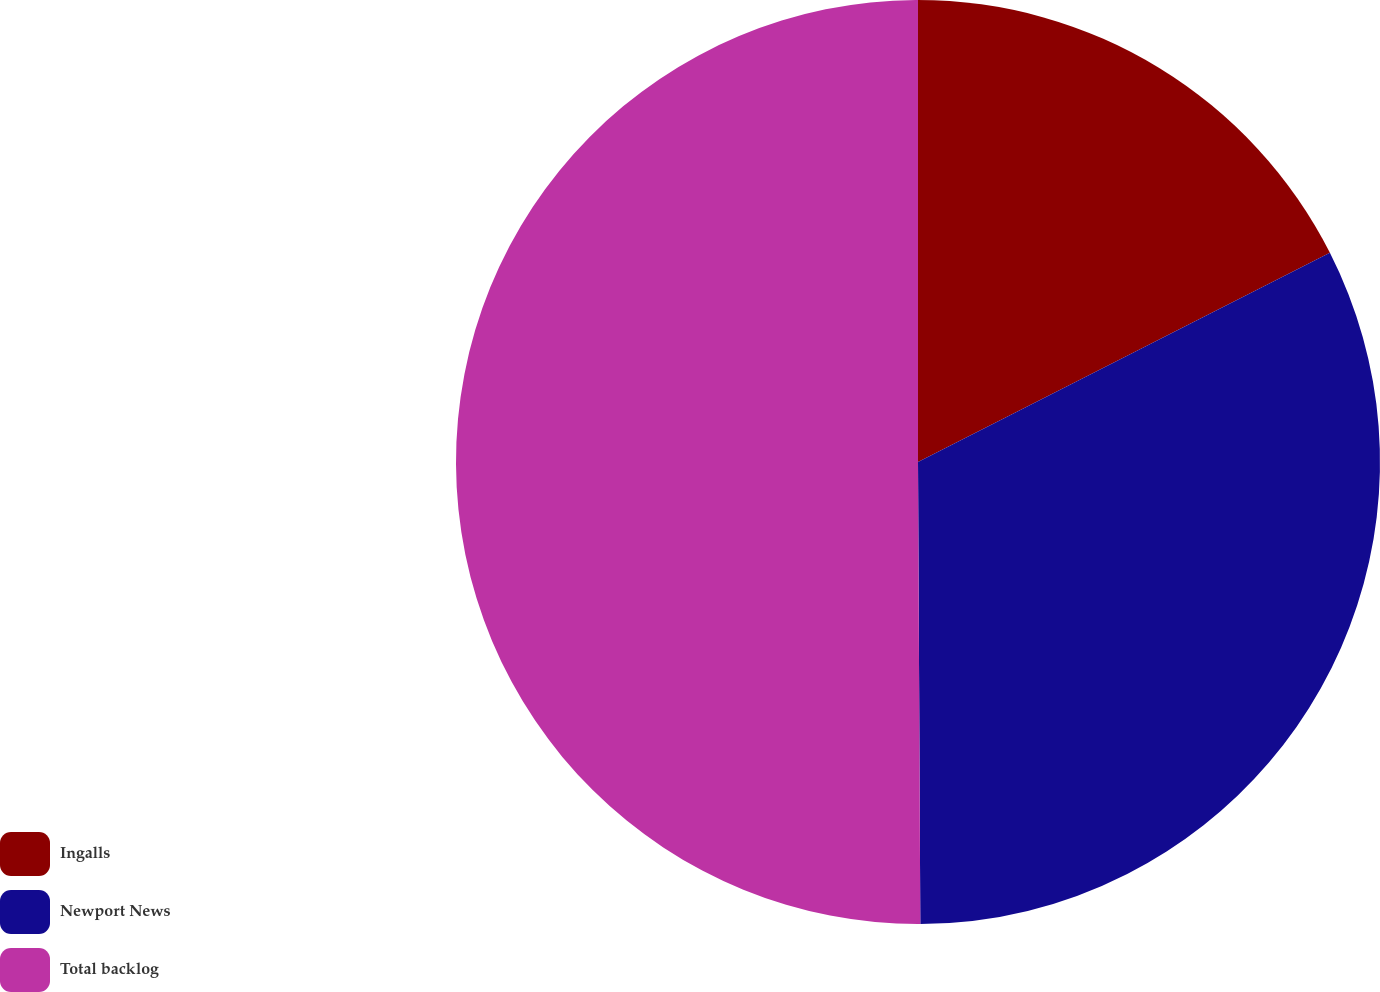<chart> <loc_0><loc_0><loc_500><loc_500><pie_chart><fcel>Ingalls<fcel>Newport News<fcel>Total backlog<nl><fcel>17.52%<fcel>32.4%<fcel>50.08%<nl></chart> 